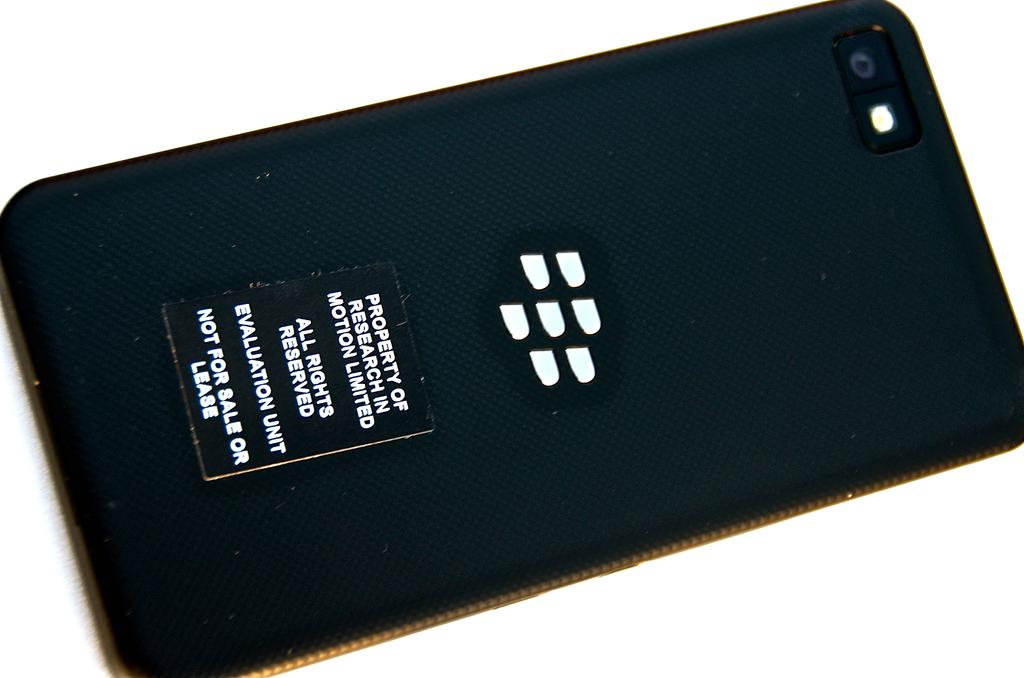<image>
Provide a brief description of the given image. The back of a cellphone stating property of research in motion and all rights reserved. 